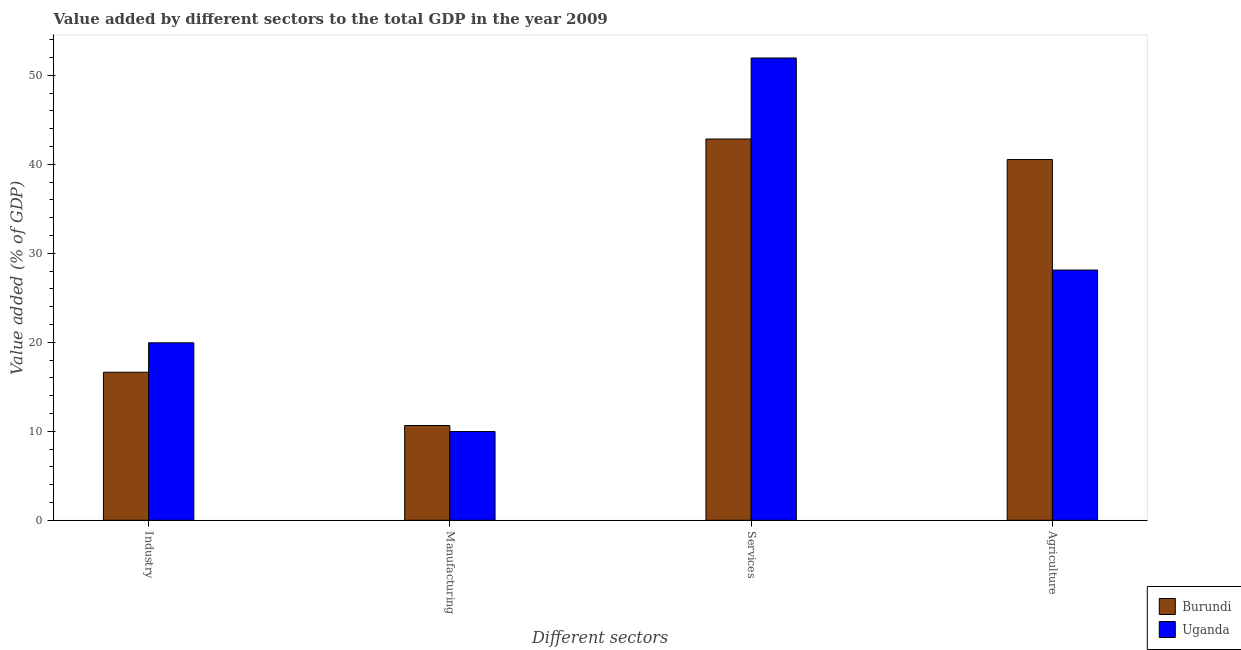How many different coloured bars are there?
Provide a short and direct response. 2. Are the number of bars per tick equal to the number of legend labels?
Your answer should be compact. Yes. Are the number of bars on each tick of the X-axis equal?
Make the answer very short. Yes. How many bars are there on the 4th tick from the left?
Give a very brief answer. 2. How many bars are there on the 3rd tick from the right?
Make the answer very short. 2. What is the label of the 4th group of bars from the left?
Your answer should be very brief. Agriculture. What is the value added by industrial sector in Uganda?
Your response must be concise. 19.94. Across all countries, what is the maximum value added by agricultural sector?
Your answer should be very brief. 40.53. Across all countries, what is the minimum value added by agricultural sector?
Offer a terse response. 28.12. In which country was the value added by agricultural sector maximum?
Ensure brevity in your answer.  Burundi. In which country was the value added by manufacturing sector minimum?
Offer a very short reply. Uganda. What is the total value added by manufacturing sector in the graph?
Provide a succinct answer. 20.62. What is the difference between the value added by agricultural sector in Burundi and that in Uganda?
Your answer should be very brief. 12.42. What is the difference between the value added by agricultural sector in Uganda and the value added by manufacturing sector in Burundi?
Provide a succinct answer. 17.47. What is the average value added by agricultural sector per country?
Your answer should be very brief. 34.32. What is the difference between the value added by industrial sector and value added by agricultural sector in Burundi?
Make the answer very short. -23.9. What is the ratio of the value added by industrial sector in Burundi to that in Uganda?
Your answer should be very brief. 0.83. Is the value added by manufacturing sector in Burundi less than that in Uganda?
Your answer should be compact. No. What is the difference between the highest and the second highest value added by agricultural sector?
Keep it short and to the point. 12.42. What is the difference between the highest and the lowest value added by industrial sector?
Your answer should be compact. 3.31. Is the sum of the value added by industrial sector in Burundi and Uganda greater than the maximum value added by services sector across all countries?
Make the answer very short. No. What does the 1st bar from the left in Industry represents?
Your answer should be very brief. Burundi. What does the 2nd bar from the right in Agriculture represents?
Your response must be concise. Burundi. Is it the case that in every country, the sum of the value added by industrial sector and value added by manufacturing sector is greater than the value added by services sector?
Give a very brief answer. No. How many bars are there?
Make the answer very short. 8. How many countries are there in the graph?
Ensure brevity in your answer.  2. What is the difference between two consecutive major ticks on the Y-axis?
Give a very brief answer. 10. Does the graph contain grids?
Provide a succinct answer. No. What is the title of the graph?
Offer a very short reply. Value added by different sectors to the total GDP in the year 2009. What is the label or title of the X-axis?
Give a very brief answer. Different sectors. What is the label or title of the Y-axis?
Offer a very short reply. Value added (% of GDP). What is the Value added (% of GDP) in Burundi in Industry?
Provide a short and direct response. 16.63. What is the Value added (% of GDP) of Uganda in Industry?
Offer a terse response. 19.94. What is the Value added (% of GDP) in Burundi in Manufacturing?
Your response must be concise. 10.65. What is the Value added (% of GDP) in Uganda in Manufacturing?
Offer a very short reply. 9.97. What is the Value added (% of GDP) in Burundi in Services?
Your response must be concise. 42.84. What is the Value added (% of GDP) in Uganda in Services?
Your response must be concise. 51.94. What is the Value added (% of GDP) in Burundi in Agriculture?
Offer a terse response. 40.53. What is the Value added (% of GDP) of Uganda in Agriculture?
Your answer should be compact. 28.12. Across all Different sectors, what is the maximum Value added (% of GDP) in Burundi?
Your answer should be compact. 42.84. Across all Different sectors, what is the maximum Value added (% of GDP) of Uganda?
Keep it short and to the point. 51.94. Across all Different sectors, what is the minimum Value added (% of GDP) of Burundi?
Offer a very short reply. 10.65. Across all Different sectors, what is the minimum Value added (% of GDP) in Uganda?
Your answer should be compact. 9.97. What is the total Value added (% of GDP) in Burundi in the graph?
Provide a short and direct response. 110.65. What is the total Value added (% of GDP) of Uganda in the graph?
Offer a terse response. 109.97. What is the difference between the Value added (% of GDP) of Burundi in Industry and that in Manufacturing?
Provide a succinct answer. 5.98. What is the difference between the Value added (% of GDP) of Uganda in Industry and that in Manufacturing?
Your answer should be compact. 9.97. What is the difference between the Value added (% of GDP) in Burundi in Industry and that in Services?
Provide a succinct answer. -26.2. What is the difference between the Value added (% of GDP) in Uganda in Industry and that in Services?
Your response must be concise. -32. What is the difference between the Value added (% of GDP) of Burundi in Industry and that in Agriculture?
Keep it short and to the point. -23.9. What is the difference between the Value added (% of GDP) of Uganda in Industry and that in Agriculture?
Keep it short and to the point. -8.17. What is the difference between the Value added (% of GDP) of Burundi in Manufacturing and that in Services?
Your answer should be very brief. -32.19. What is the difference between the Value added (% of GDP) in Uganda in Manufacturing and that in Services?
Offer a very short reply. -41.97. What is the difference between the Value added (% of GDP) of Burundi in Manufacturing and that in Agriculture?
Your answer should be compact. -29.89. What is the difference between the Value added (% of GDP) of Uganda in Manufacturing and that in Agriculture?
Give a very brief answer. -18.14. What is the difference between the Value added (% of GDP) in Burundi in Services and that in Agriculture?
Give a very brief answer. 2.3. What is the difference between the Value added (% of GDP) in Uganda in Services and that in Agriculture?
Make the answer very short. 23.83. What is the difference between the Value added (% of GDP) in Burundi in Industry and the Value added (% of GDP) in Uganda in Manufacturing?
Your answer should be very brief. 6.66. What is the difference between the Value added (% of GDP) of Burundi in Industry and the Value added (% of GDP) of Uganda in Services?
Offer a terse response. -35.31. What is the difference between the Value added (% of GDP) of Burundi in Industry and the Value added (% of GDP) of Uganda in Agriculture?
Offer a very short reply. -11.48. What is the difference between the Value added (% of GDP) in Burundi in Manufacturing and the Value added (% of GDP) in Uganda in Services?
Your answer should be very brief. -41.3. What is the difference between the Value added (% of GDP) of Burundi in Manufacturing and the Value added (% of GDP) of Uganda in Agriculture?
Your answer should be compact. -17.47. What is the difference between the Value added (% of GDP) in Burundi in Services and the Value added (% of GDP) in Uganda in Agriculture?
Make the answer very short. 14.72. What is the average Value added (% of GDP) of Burundi per Different sectors?
Your response must be concise. 27.66. What is the average Value added (% of GDP) in Uganda per Different sectors?
Give a very brief answer. 27.49. What is the difference between the Value added (% of GDP) in Burundi and Value added (% of GDP) in Uganda in Industry?
Provide a short and direct response. -3.31. What is the difference between the Value added (% of GDP) in Burundi and Value added (% of GDP) in Uganda in Manufacturing?
Your response must be concise. 0.68. What is the difference between the Value added (% of GDP) in Burundi and Value added (% of GDP) in Uganda in Services?
Your answer should be very brief. -9.11. What is the difference between the Value added (% of GDP) in Burundi and Value added (% of GDP) in Uganda in Agriculture?
Offer a terse response. 12.42. What is the ratio of the Value added (% of GDP) in Burundi in Industry to that in Manufacturing?
Your answer should be very brief. 1.56. What is the ratio of the Value added (% of GDP) of Uganda in Industry to that in Manufacturing?
Your answer should be compact. 2. What is the ratio of the Value added (% of GDP) of Burundi in Industry to that in Services?
Offer a terse response. 0.39. What is the ratio of the Value added (% of GDP) of Uganda in Industry to that in Services?
Your answer should be compact. 0.38. What is the ratio of the Value added (% of GDP) in Burundi in Industry to that in Agriculture?
Make the answer very short. 0.41. What is the ratio of the Value added (% of GDP) of Uganda in Industry to that in Agriculture?
Your answer should be very brief. 0.71. What is the ratio of the Value added (% of GDP) of Burundi in Manufacturing to that in Services?
Offer a very short reply. 0.25. What is the ratio of the Value added (% of GDP) of Uganda in Manufacturing to that in Services?
Give a very brief answer. 0.19. What is the ratio of the Value added (% of GDP) of Burundi in Manufacturing to that in Agriculture?
Your answer should be compact. 0.26. What is the ratio of the Value added (% of GDP) in Uganda in Manufacturing to that in Agriculture?
Offer a very short reply. 0.35. What is the ratio of the Value added (% of GDP) of Burundi in Services to that in Agriculture?
Give a very brief answer. 1.06. What is the ratio of the Value added (% of GDP) in Uganda in Services to that in Agriculture?
Your answer should be compact. 1.85. What is the difference between the highest and the second highest Value added (% of GDP) in Burundi?
Give a very brief answer. 2.3. What is the difference between the highest and the second highest Value added (% of GDP) of Uganda?
Offer a very short reply. 23.83. What is the difference between the highest and the lowest Value added (% of GDP) in Burundi?
Your answer should be very brief. 32.19. What is the difference between the highest and the lowest Value added (% of GDP) in Uganda?
Keep it short and to the point. 41.97. 